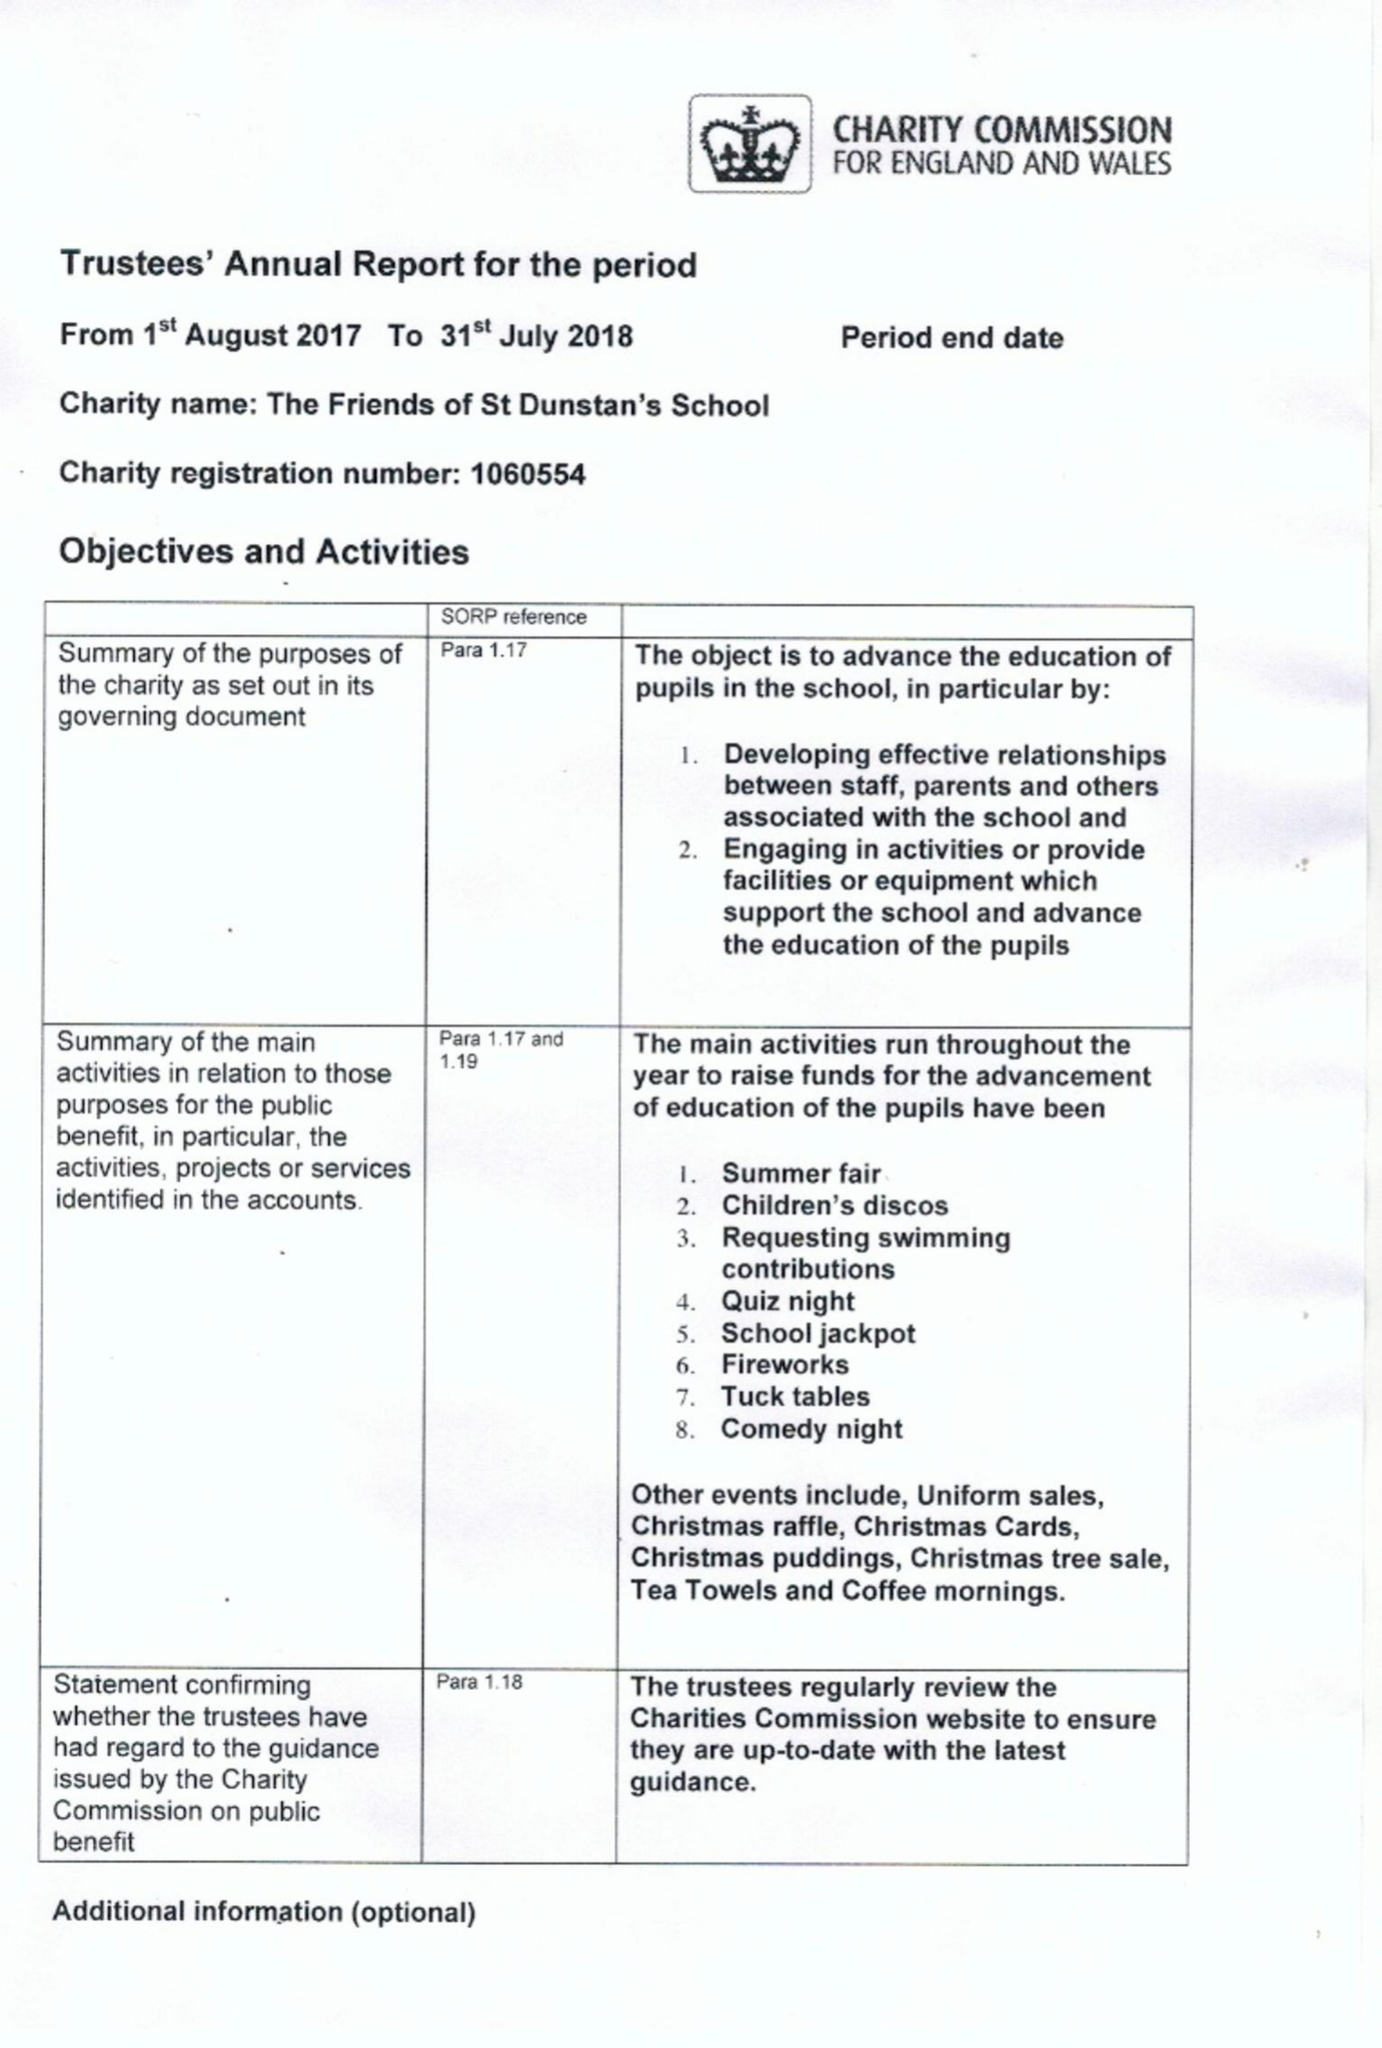What is the value for the spending_annually_in_british_pounds?
Answer the question using a single word or phrase. 56467.00 